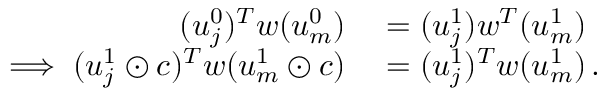<formula> <loc_0><loc_0><loc_500><loc_500>\begin{array} { r l } { ( u _ { j } ^ { 0 } ) ^ { T } w ( u _ { m } ^ { 0 } ) } & = ( u _ { j } ^ { 1 } ) w ^ { T } ( u _ { m } ^ { 1 } ) } \\ { \implies ( u _ { j } ^ { 1 } \odot c ) ^ { T } w ( u _ { m } ^ { 1 } \odot c ) } & = ( u _ { j } ^ { 1 } ) ^ { T } w ( u _ { m } ^ { 1 } ) \, . } \end{array}</formula> 